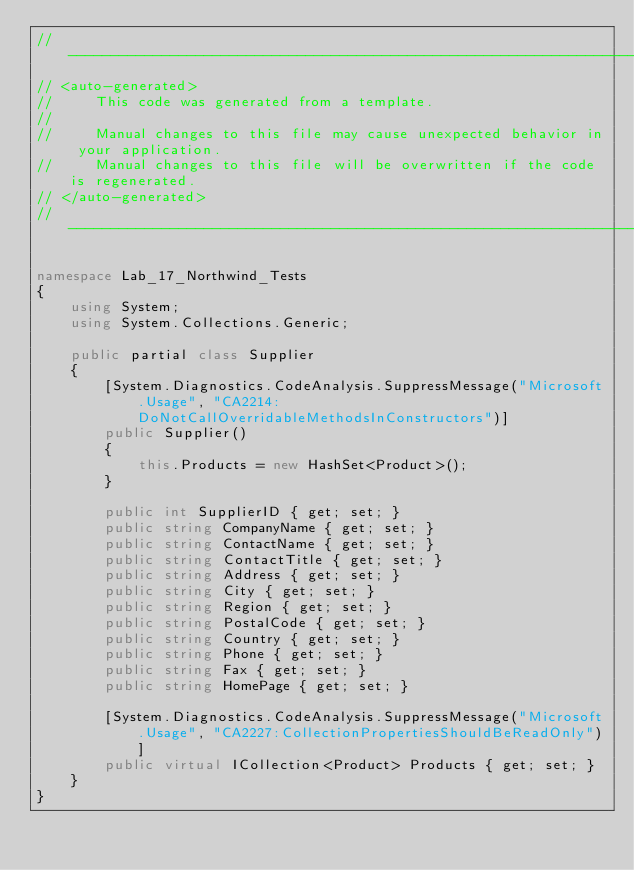Convert code to text. <code><loc_0><loc_0><loc_500><loc_500><_C#_>//------------------------------------------------------------------------------
// <auto-generated>
//     This code was generated from a template.
//
//     Manual changes to this file may cause unexpected behavior in your application.
//     Manual changes to this file will be overwritten if the code is regenerated.
// </auto-generated>
//------------------------------------------------------------------------------

namespace Lab_17_Northwind_Tests
{
    using System;
    using System.Collections.Generic;
    
    public partial class Supplier
    {
        [System.Diagnostics.CodeAnalysis.SuppressMessage("Microsoft.Usage", "CA2214:DoNotCallOverridableMethodsInConstructors")]
        public Supplier()
        {
            this.Products = new HashSet<Product>();
        }
    
        public int SupplierID { get; set; }
        public string CompanyName { get; set; }
        public string ContactName { get; set; }
        public string ContactTitle { get; set; }
        public string Address { get; set; }
        public string City { get; set; }
        public string Region { get; set; }
        public string PostalCode { get; set; }
        public string Country { get; set; }
        public string Phone { get; set; }
        public string Fax { get; set; }
        public string HomePage { get; set; }
    
        [System.Diagnostics.CodeAnalysis.SuppressMessage("Microsoft.Usage", "CA2227:CollectionPropertiesShouldBeReadOnly")]
        public virtual ICollection<Product> Products { get; set; }
    }
}
</code> 